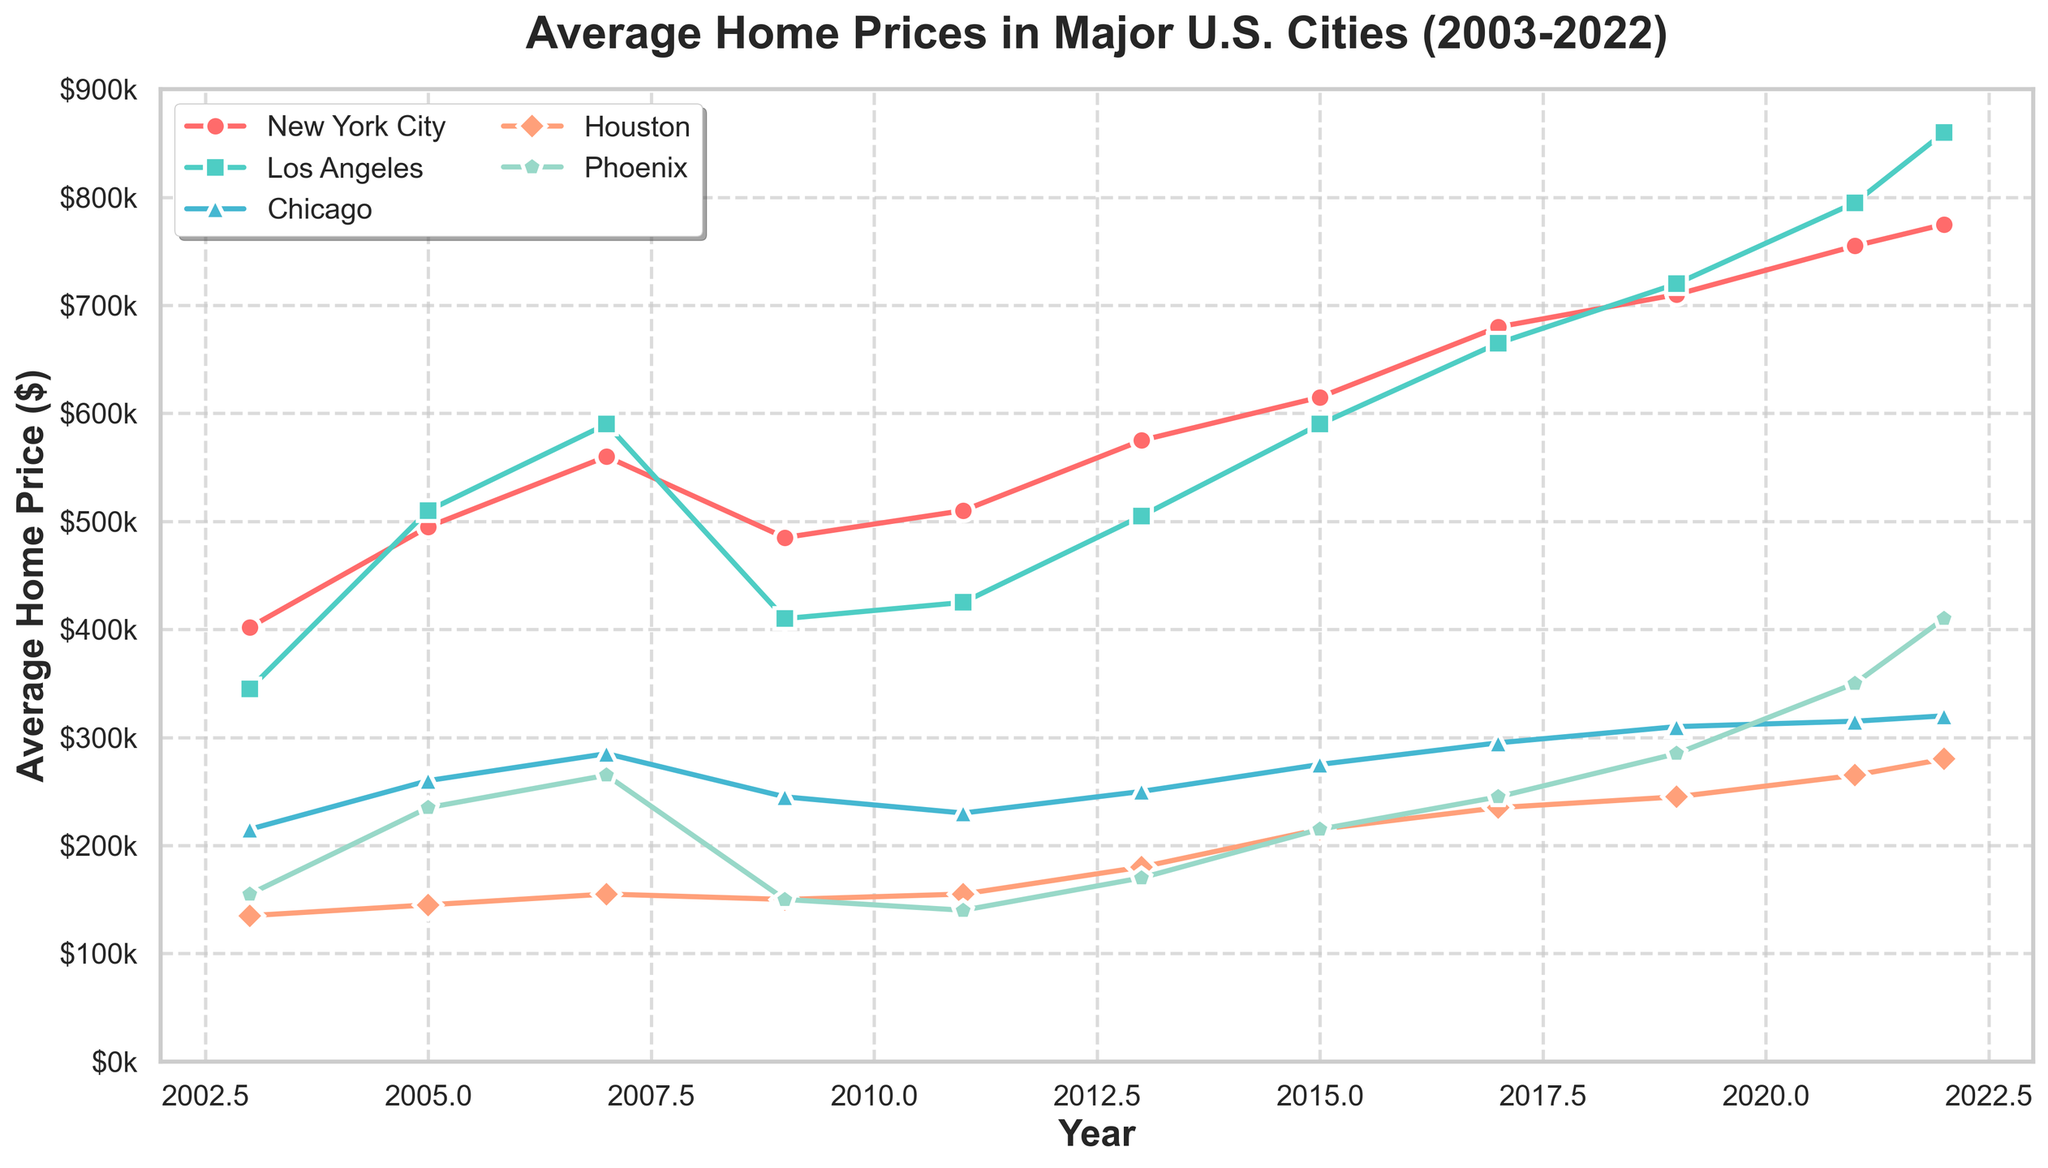What is the trend of average home prices in New York City from 2003 to 2022? To determine the trend, observe the line representing New York City over the years. It starts at $402,000 in 2003 and gradually increases, reaching $775,000 in 2022. The overall trend is an upward trajectory.
Answer: Upward trend Which city had the highest average home price in 2022? In 2022, compare the data points for each city. The line for Los Angeles peaks at $860,000, the highest among all cities.
Answer: Los Angeles Between which two years did Houston experience the largest increase in average home prices? To find this, observe the changes in Houston's line. The substantial increase occurs from 2013 ($180,000) to 2015 ($215,000). Calculate the differences for confirmation: (215,000 - 180,000 = 35,000).
Answer: 2013-2015 How does the average home price in Phoenix in 2022 compare to that in 2009? Check the points for Phoenix in 2009 ($150,000) and 2022 ($410,000). The prices increased significantly.
Answer: Increased In which years did Chicago see a decrease in average home prices? Examine Chicago's line for any downward slopes. Decreases are seen from 2007 to 2009 ($285,000 to $245,000) and from 2009 to 2011 ($245,000 to $230,000).
Answer: 2007-2009, 2009-2011 Which city had the most stable average home prices over the 20 years? A stable line has minimal fluctuations. Chicago's line is comparatively less variable with smaller changes over the years.
Answer: Chicago Compare the average home prices in New York City and Los Angeles in 2005. Which city had higher prices and by how much? Look at the 2005 points for both cities: New York City ($495,000) and Los Angeles ($510,000). Los Angeles prices are higher. The difference is $510,000 - $495,000 = $15,000.
Answer: Los Angeles by $15,000 What is the percentage increase in average home prices in Phoenix from 2013 to 2022? First, note the prices: $170,000 in 2013 and $410,000 in 2022. Calculate the increase: $410,000 - $170,000 = $240,000. Then, find the percentage: ($240,000 / $170,000) * 100 ≈ 141.18%.
Answer: ≈ 141.18% Among the five cities shown, which one had the lowest average home price in 2011, and what was it? Check all cities' data for 2011. Phoenix had the lowest average home price at $140,000.
Answer: Phoenix, $140,000 